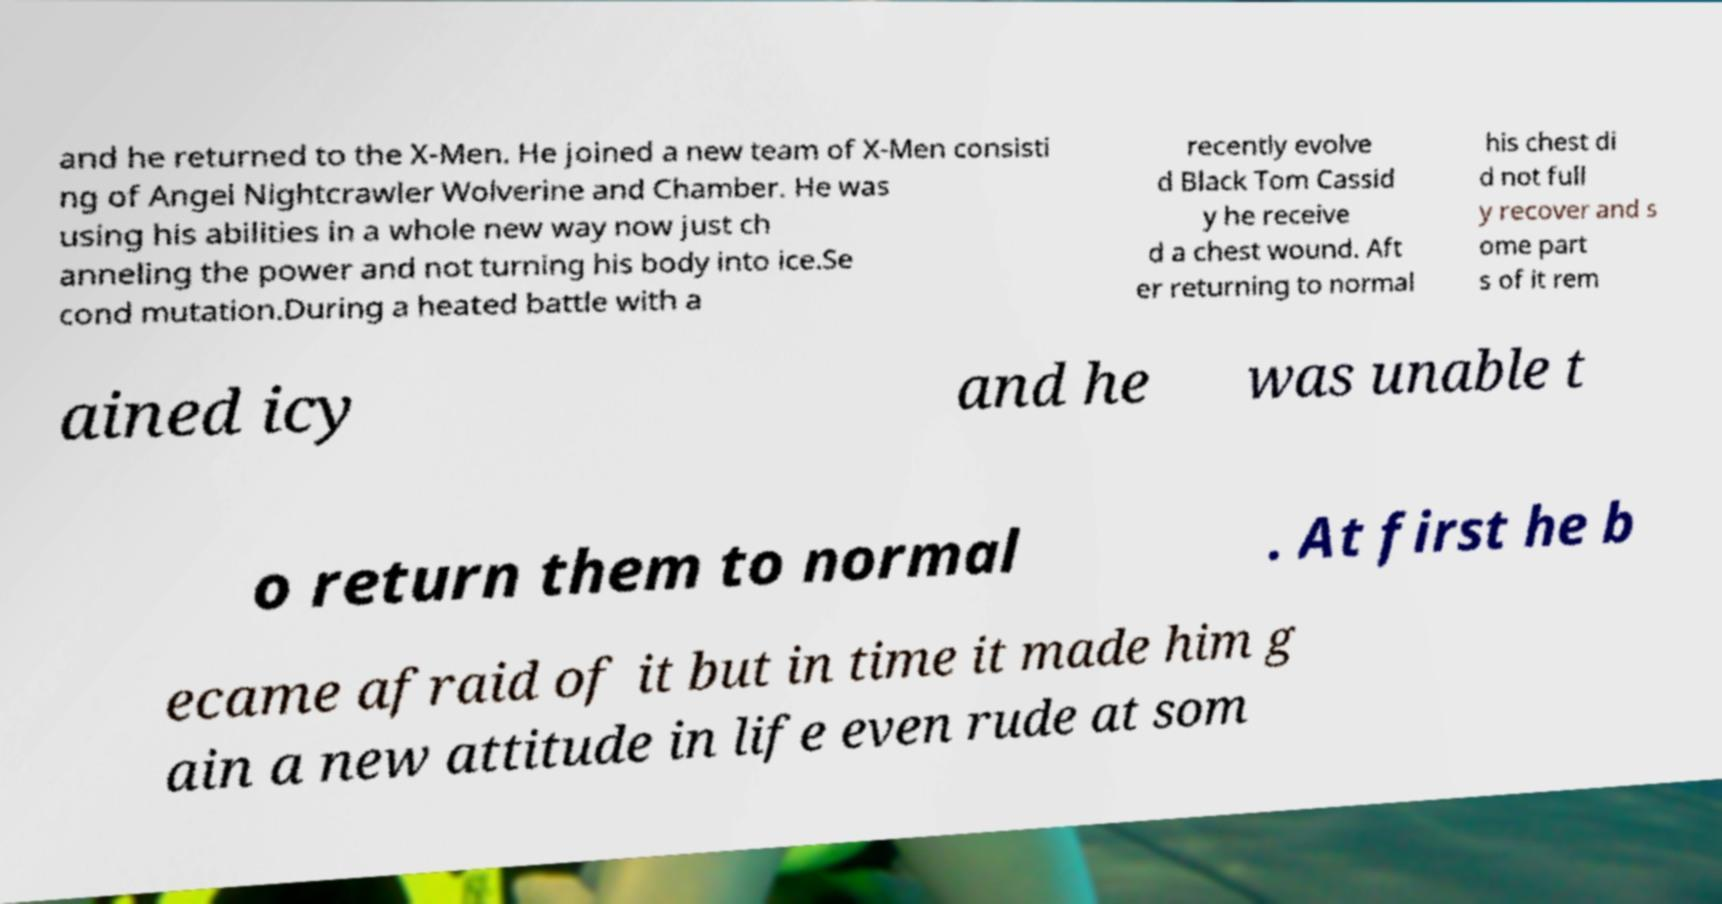I need the written content from this picture converted into text. Can you do that? and he returned to the X-Men. He joined a new team of X-Men consisti ng of Angel Nightcrawler Wolverine and Chamber. He was using his abilities in a whole new way now just ch anneling the power and not turning his body into ice.Se cond mutation.During a heated battle with a recently evolve d Black Tom Cassid y he receive d a chest wound. Aft er returning to normal his chest di d not full y recover and s ome part s of it rem ained icy and he was unable t o return them to normal . At first he b ecame afraid of it but in time it made him g ain a new attitude in life even rude at som 